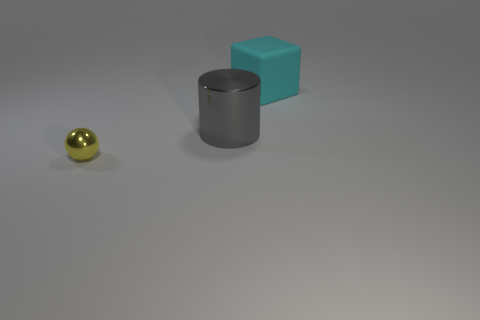Add 2 tiny yellow metallic balls. How many objects exist? 5 Subtract all balls. How many objects are left? 2 Add 1 gray metallic objects. How many gray metallic objects are left? 2 Add 2 big gray things. How many big gray things exist? 3 Subtract 0 red cylinders. How many objects are left? 3 Subtract all small yellow metallic balls. Subtract all gray metallic objects. How many objects are left? 1 